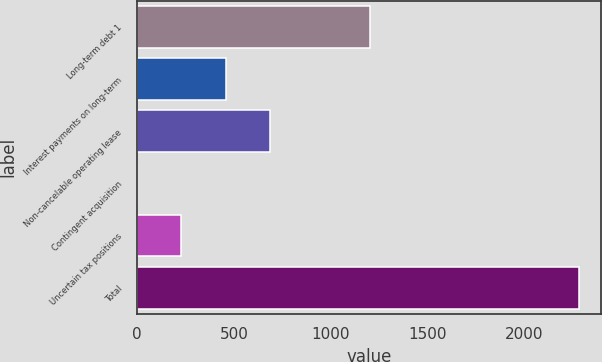Convert chart to OTSL. <chart><loc_0><loc_0><loc_500><loc_500><bar_chart><fcel>Long-term debt 1<fcel>Interest payments on long-term<fcel>Non-cancelable operating lease<fcel>Contingent acquisition<fcel>Uncertain tax positions<fcel>Total<nl><fcel>1200.2<fcel>456.06<fcel>683.94<fcel>0.3<fcel>228.18<fcel>2279.1<nl></chart> 